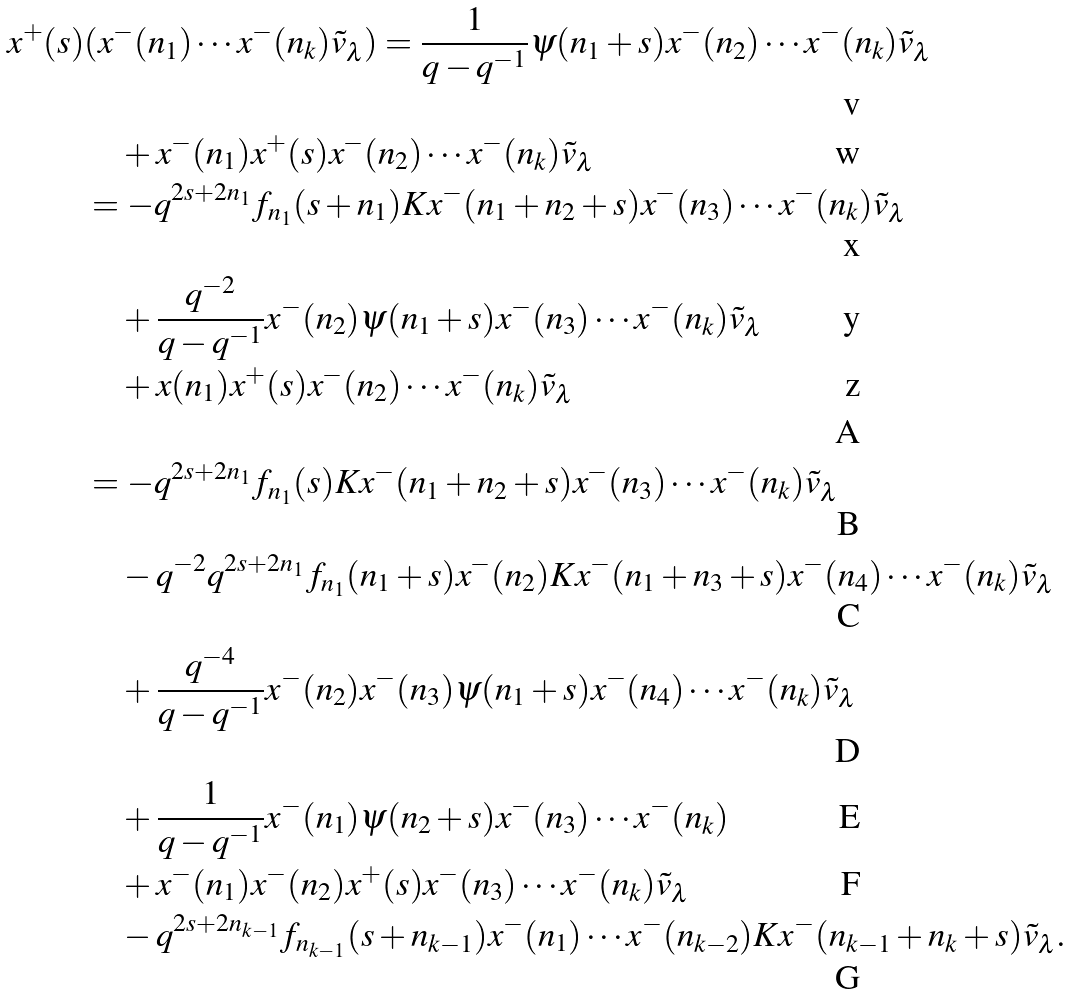Convert formula to latex. <formula><loc_0><loc_0><loc_500><loc_500>x ^ { + } ( s ) & ( x ^ { - } ( n _ { 1 } ) \cdots x ^ { - } ( n _ { k } ) \tilde { v } _ { \lambda } ) = \frac { 1 } { q - q ^ { - 1 } } \psi ( n _ { 1 } + s ) x ^ { - } ( n _ { 2 } ) \cdots x ^ { - } ( n _ { k } ) \tilde { v } _ { \lambda } \\ & \quad + x ^ { - } ( n _ { 1 } ) x ^ { + } ( s ) x ^ { - } ( n _ { 2 } ) \cdots x ^ { - } ( n _ { k } ) \tilde { v } _ { \lambda } \\ & = - q ^ { 2 s + 2 n _ { 1 } } f _ { n _ { 1 } } ( s + n _ { 1 } ) K x ^ { - } ( n _ { 1 } + n _ { 2 } + s ) x ^ { - } ( n _ { 3 } ) \cdots x ^ { - } ( n _ { k } ) \tilde { v } _ { \lambda } \\ & \quad + \frac { q ^ { - 2 } } { q - q ^ { - 1 } } x ^ { - } ( n _ { 2 } ) \psi ( n _ { 1 } + s ) x ^ { - } ( n _ { 3 } ) \cdots x ^ { - } ( n _ { k } ) \tilde { v } _ { \lambda } \\ & \quad + x ( n _ { 1 } ) x ^ { + } ( s ) x ^ { - } ( n _ { 2 } ) \cdots x ^ { - } ( n _ { k } ) \tilde { v } _ { \lambda } \\ \\ & = - q ^ { 2 s + 2 n _ { 1 } } f _ { n _ { 1 } } ( s ) K x ^ { - } ( n _ { 1 } + n _ { 2 } + s ) x ^ { - } ( n _ { 3 } ) \cdots x ^ { - } ( n _ { k } ) \tilde { v } _ { \lambda } \\ & \quad - q ^ { - 2 } q ^ { 2 s + 2 n _ { 1 } } f _ { n _ { 1 } } ( n _ { 1 } + s ) x ^ { - } ( n _ { 2 } ) K x ^ { - } ( n _ { 1 } + n _ { 3 } + s ) x ^ { - } ( n _ { 4 } ) \cdots x ^ { - } ( n _ { k } ) \tilde { v } _ { \lambda } \\ & \quad + \frac { q ^ { - 4 } } { q - q ^ { - 1 } } x ^ { - } ( n _ { 2 } ) x ^ { - } ( n _ { 3 } ) \psi ( n _ { 1 } + s ) x ^ { - } ( n _ { 4 } ) \cdots x ^ { - } ( n _ { k } ) \tilde { v } _ { \lambda } \\ & \quad + \frac { 1 } { q - q ^ { - 1 } } x ^ { - } ( n _ { 1 } ) \psi ( n _ { 2 } + s ) x ^ { - } ( n _ { 3 } ) \cdots x ^ { - } ( n _ { k } ) \\ & \quad + x ^ { - } ( n _ { 1 } ) x ^ { - } ( n _ { 2 } ) x ^ { + } ( s ) x ^ { - } ( n _ { 3 } ) \cdots x ^ { - } ( n _ { k } ) \tilde { v } _ { \lambda } \\ & \quad - q ^ { 2 s + 2 n _ { k - 1 } } f _ { n _ { k - 1 } } ( s + n _ { k - 1 } ) x ^ { - } ( n _ { 1 } ) \cdots x ^ { - } ( n _ { k - 2 } ) K x ^ { - } ( n _ { k - 1 } + n _ { k } + s ) \tilde { v } _ { \lambda } .</formula> 